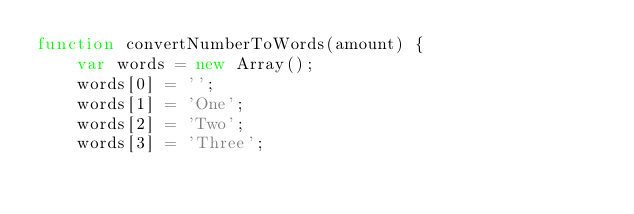<code> <loc_0><loc_0><loc_500><loc_500><_JavaScript_>function convertNumberToWords(amount) {
    var words = new Array();
    words[0] = '';
    words[1] = 'One';
    words[2] = 'Two';
    words[3] = 'Three';</code> 